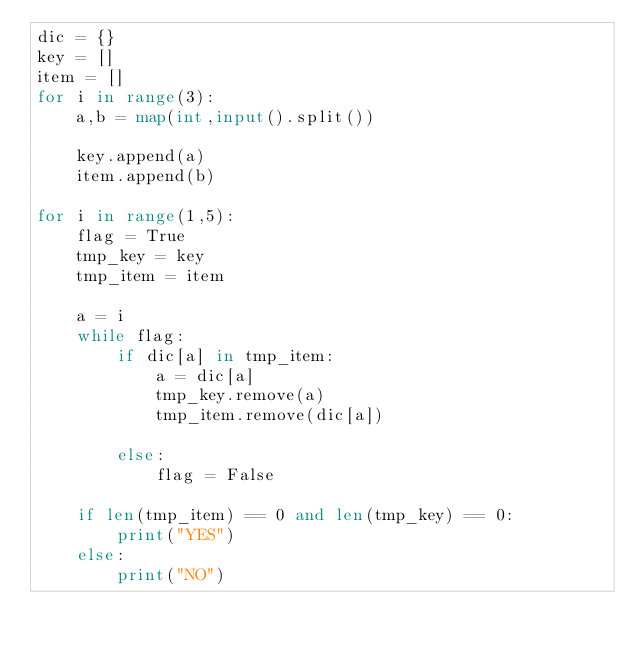Convert code to text. <code><loc_0><loc_0><loc_500><loc_500><_Python_>dic = {}
key = []
item = []
for i in range(3):
    a,b = map(int,input().split())
    
    key.append(a)
    item.append(b)

for i in range(1,5):
    flag = True
    tmp_key = key
    tmp_item = item
    
    a = i
    while flag:
        if dic[a] in tmp_item:
            a = dic[a]
            tmp_key.remove(a)
            tmp_item.remove(dic[a])
            
        else:
            flag = False
        
    if len(tmp_item) == 0 and len(tmp_key) == 0:
        print("YES")
    else:
        print("NO")

        

</code> 